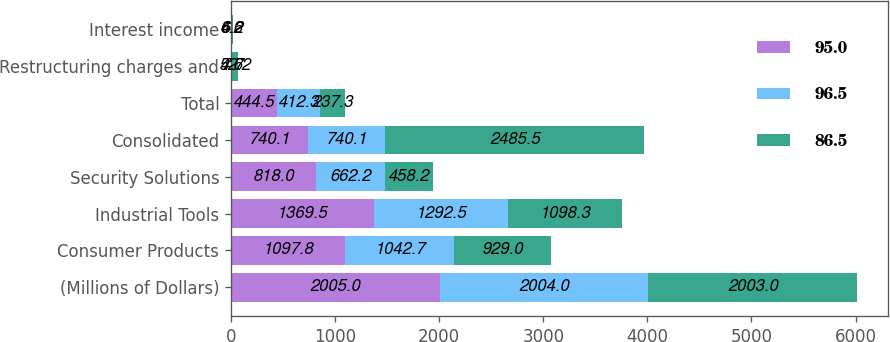Convert chart to OTSL. <chart><loc_0><loc_0><loc_500><loc_500><stacked_bar_chart><ecel><fcel>(Millions of Dollars)<fcel>Consumer Products<fcel>Industrial Tools<fcel>Security Solutions<fcel>Consolidated<fcel>Total<fcel>Restructuring charges and<fcel>Interest income<nl><fcel>95<fcel>2005<fcel>1097.8<fcel>1369.5<fcel>818<fcel>740.1<fcel>444.5<fcel>4.6<fcel>6.6<nl><fcel>96.5<fcel>2004<fcel>1042.7<fcel>1292.5<fcel>662.2<fcel>740.1<fcel>412.3<fcel>7.7<fcel>4.2<nl><fcel>86.5<fcel>2003<fcel>929<fcel>1098.3<fcel>458.2<fcel>2485.5<fcel>237.3<fcel>52.2<fcel>6.2<nl></chart> 